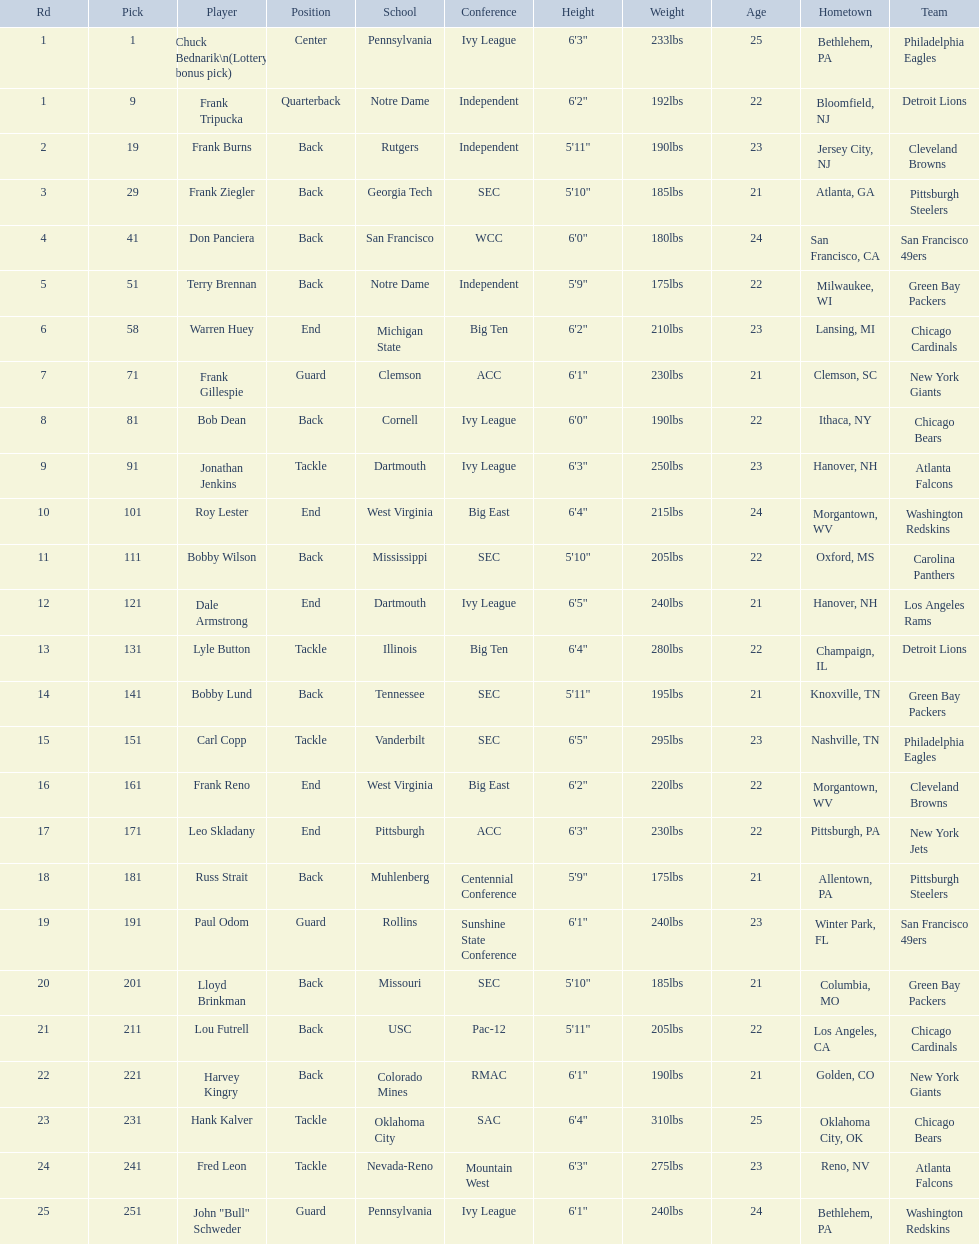Who was selected following frank burns? Frank Ziegler. 